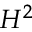Convert formula to latex. <formula><loc_0><loc_0><loc_500><loc_500>H ^ { 2 }</formula> 